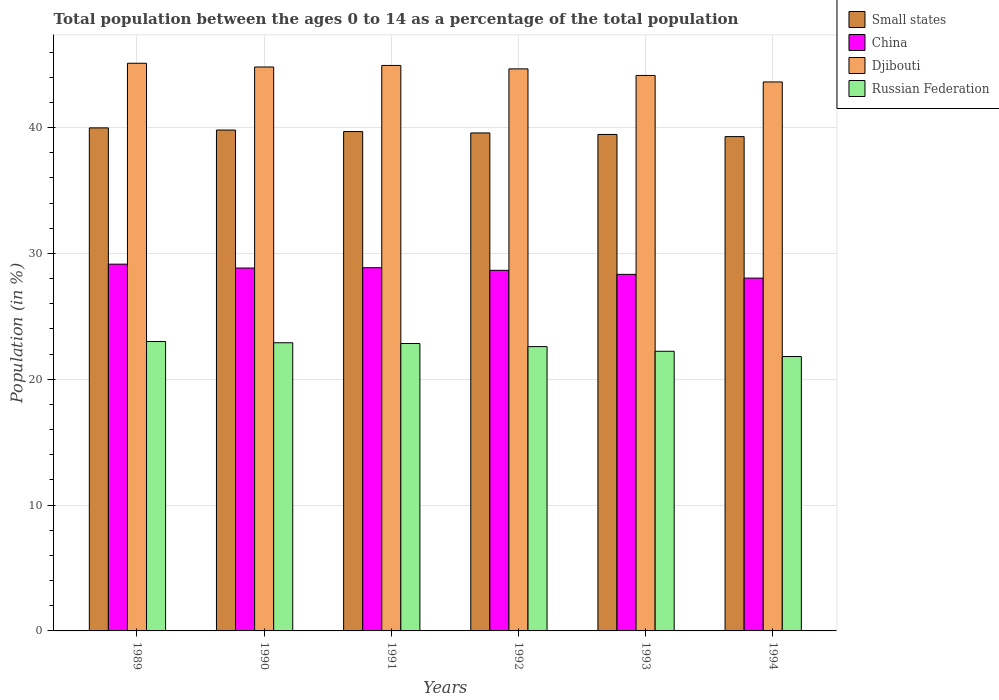Are the number of bars per tick equal to the number of legend labels?
Offer a terse response. Yes. Are the number of bars on each tick of the X-axis equal?
Keep it short and to the point. Yes. What is the label of the 2nd group of bars from the left?
Give a very brief answer. 1990. In how many cases, is the number of bars for a given year not equal to the number of legend labels?
Give a very brief answer. 0. What is the percentage of the population ages 0 to 14 in China in 1989?
Offer a terse response. 29.15. Across all years, what is the maximum percentage of the population ages 0 to 14 in Russian Federation?
Make the answer very short. 23. Across all years, what is the minimum percentage of the population ages 0 to 14 in Small states?
Provide a succinct answer. 39.29. What is the total percentage of the population ages 0 to 14 in China in the graph?
Provide a short and direct response. 171.9. What is the difference between the percentage of the population ages 0 to 14 in Russian Federation in 1991 and that in 1994?
Offer a terse response. 1.03. What is the difference between the percentage of the population ages 0 to 14 in Small states in 1989 and the percentage of the population ages 0 to 14 in Russian Federation in 1991?
Make the answer very short. 17.14. What is the average percentage of the population ages 0 to 14 in Russian Federation per year?
Keep it short and to the point. 22.56. In the year 1989, what is the difference between the percentage of the population ages 0 to 14 in Small states and percentage of the population ages 0 to 14 in China?
Give a very brief answer. 10.83. In how many years, is the percentage of the population ages 0 to 14 in China greater than 8?
Provide a short and direct response. 6. What is the ratio of the percentage of the population ages 0 to 14 in Russian Federation in 1990 to that in 1992?
Make the answer very short. 1.01. Is the percentage of the population ages 0 to 14 in China in 1990 less than that in 1994?
Your answer should be compact. No. Is the difference between the percentage of the population ages 0 to 14 in Small states in 1990 and 1991 greater than the difference between the percentage of the population ages 0 to 14 in China in 1990 and 1991?
Your answer should be very brief. Yes. What is the difference between the highest and the second highest percentage of the population ages 0 to 14 in China?
Provide a succinct answer. 0.28. What is the difference between the highest and the lowest percentage of the population ages 0 to 14 in Russian Federation?
Your answer should be compact. 1.19. In how many years, is the percentage of the population ages 0 to 14 in Djibouti greater than the average percentage of the population ages 0 to 14 in Djibouti taken over all years?
Ensure brevity in your answer.  4. Is the sum of the percentage of the population ages 0 to 14 in China in 1993 and 1994 greater than the maximum percentage of the population ages 0 to 14 in Small states across all years?
Your answer should be very brief. Yes. Is it the case that in every year, the sum of the percentage of the population ages 0 to 14 in Small states and percentage of the population ages 0 to 14 in Djibouti is greater than the sum of percentage of the population ages 0 to 14 in China and percentage of the population ages 0 to 14 in Russian Federation?
Your response must be concise. Yes. What does the 3rd bar from the left in 1990 represents?
Provide a short and direct response. Djibouti. What does the 2nd bar from the right in 1989 represents?
Ensure brevity in your answer.  Djibouti. Is it the case that in every year, the sum of the percentage of the population ages 0 to 14 in Small states and percentage of the population ages 0 to 14 in Djibouti is greater than the percentage of the population ages 0 to 14 in China?
Provide a short and direct response. Yes. Are all the bars in the graph horizontal?
Make the answer very short. No. How many years are there in the graph?
Your response must be concise. 6. What is the difference between two consecutive major ticks on the Y-axis?
Keep it short and to the point. 10. Does the graph contain any zero values?
Offer a very short reply. No. Does the graph contain grids?
Offer a terse response. Yes. Where does the legend appear in the graph?
Ensure brevity in your answer.  Top right. How are the legend labels stacked?
Offer a terse response. Vertical. What is the title of the graph?
Make the answer very short. Total population between the ages 0 to 14 as a percentage of the total population. Does "World" appear as one of the legend labels in the graph?
Ensure brevity in your answer.  No. What is the Population (in %) of Small states in 1989?
Make the answer very short. 39.98. What is the Population (in %) of China in 1989?
Your response must be concise. 29.15. What is the Population (in %) in Djibouti in 1989?
Your answer should be compact. 45.12. What is the Population (in %) of Russian Federation in 1989?
Ensure brevity in your answer.  23. What is the Population (in %) of Small states in 1990?
Offer a terse response. 39.81. What is the Population (in %) in China in 1990?
Provide a succinct answer. 28.84. What is the Population (in %) in Djibouti in 1990?
Your answer should be compact. 44.82. What is the Population (in %) in Russian Federation in 1990?
Ensure brevity in your answer.  22.9. What is the Population (in %) in Small states in 1991?
Give a very brief answer. 39.69. What is the Population (in %) in China in 1991?
Make the answer very short. 28.87. What is the Population (in %) of Djibouti in 1991?
Make the answer very short. 44.94. What is the Population (in %) of Russian Federation in 1991?
Your answer should be compact. 22.84. What is the Population (in %) in Small states in 1992?
Offer a very short reply. 39.58. What is the Population (in %) in China in 1992?
Keep it short and to the point. 28.66. What is the Population (in %) in Djibouti in 1992?
Provide a succinct answer. 44.67. What is the Population (in %) of Russian Federation in 1992?
Your response must be concise. 22.6. What is the Population (in %) of Small states in 1993?
Offer a very short reply. 39.46. What is the Population (in %) in China in 1993?
Keep it short and to the point. 28.34. What is the Population (in %) in Djibouti in 1993?
Your response must be concise. 44.15. What is the Population (in %) of Russian Federation in 1993?
Your answer should be very brief. 22.23. What is the Population (in %) of Small states in 1994?
Keep it short and to the point. 39.29. What is the Population (in %) of China in 1994?
Your response must be concise. 28.04. What is the Population (in %) in Djibouti in 1994?
Ensure brevity in your answer.  43.63. What is the Population (in %) in Russian Federation in 1994?
Offer a terse response. 21.81. Across all years, what is the maximum Population (in %) of Small states?
Offer a terse response. 39.98. Across all years, what is the maximum Population (in %) of China?
Offer a very short reply. 29.15. Across all years, what is the maximum Population (in %) of Djibouti?
Offer a terse response. 45.12. Across all years, what is the maximum Population (in %) of Russian Federation?
Give a very brief answer. 23. Across all years, what is the minimum Population (in %) of Small states?
Your response must be concise. 39.29. Across all years, what is the minimum Population (in %) in China?
Offer a very short reply. 28.04. Across all years, what is the minimum Population (in %) in Djibouti?
Ensure brevity in your answer.  43.63. Across all years, what is the minimum Population (in %) in Russian Federation?
Give a very brief answer. 21.81. What is the total Population (in %) in Small states in the graph?
Keep it short and to the point. 237.81. What is the total Population (in %) in China in the graph?
Ensure brevity in your answer.  171.9. What is the total Population (in %) in Djibouti in the graph?
Your response must be concise. 267.33. What is the total Population (in %) in Russian Federation in the graph?
Provide a succinct answer. 135.38. What is the difference between the Population (in %) in Small states in 1989 and that in 1990?
Provide a short and direct response. 0.17. What is the difference between the Population (in %) of China in 1989 and that in 1990?
Keep it short and to the point. 0.31. What is the difference between the Population (in %) in Djibouti in 1989 and that in 1990?
Provide a succinct answer. 0.3. What is the difference between the Population (in %) of Russian Federation in 1989 and that in 1990?
Your answer should be very brief. 0.1. What is the difference between the Population (in %) of Small states in 1989 and that in 1991?
Ensure brevity in your answer.  0.29. What is the difference between the Population (in %) of China in 1989 and that in 1991?
Offer a terse response. 0.28. What is the difference between the Population (in %) in Djibouti in 1989 and that in 1991?
Give a very brief answer. 0.17. What is the difference between the Population (in %) in Russian Federation in 1989 and that in 1991?
Ensure brevity in your answer.  0.16. What is the difference between the Population (in %) in Small states in 1989 and that in 1992?
Your response must be concise. 0.4. What is the difference between the Population (in %) of China in 1989 and that in 1992?
Make the answer very short. 0.49. What is the difference between the Population (in %) of Djibouti in 1989 and that in 1992?
Your answer should be compact. 0.45. What is the difference between the Population (in %) in Russian Federation in 1989 and that in 1992?
Provide a short and direct response. 0.4. What is the difference between the Population (in %) of Small states in 1989 and that in 1993?
Make the answer very short. 0.52. What is the difference between the Population (in %) in China in 1989 and that in 1993?
Ensure brevity in your answer.  0.81. What is the difference between the Population (in %) in Djibouti in 1989 and that in 1993?
Your answer should be very brief. 0.97. What is the difference between the Population (in %) in Russian Federation in 1989 and that in 1993?
Offer a very short reply. 0.78. What is the difference between the Population (in %) of Small states in 1989 and that in 1994?
Your answer should be compact. 0.69. What is the difference between the Population (in %) of China in 1989 and that in 1994?
Provide a succinct answer. 1.11. What is the difference between the Population (in %) in Djibouti in 1989 and that in 1994?
Provide a short and direct response. 1.48. What is the difference between the Population (in %) in Russian Federation in 1989 and that in 1994?
Ensure brevity in your answer.  1.19. What is the difference between the Population (in %) of Small states in 1990 and that in 1991?
Provide a short and direct response. 0.12. What is the difference between the Population (in %) of China in 1990 and that in 1991?
Offer a very short reply. -0.03. What is the difference between the Population (in %) of Djibouti in 1990 and that in 1991?
Your answer should be very brief. -0.12. What is the difference between the Population (in %) in Russian Federation in 1990 and that in 1991?
Your response must be concise. 0.06. What is the difference between the Population (in %) of Small states in 1990 and that in 1992?
Provide a succinct answer. 0.23. What is the difference between the Population (in %) in China in 1990 and that in 1992?
Your response must be concise. 0.18. What is the difference between the Population (in %) in Djibouti in 1990 and that in 1992?
Provide a succinct answer. 0.15. What is the difference between the Population (in %) in Russian Federation in 1990 and that in 1992?
Your response must be concise. 0.31. What is the difference between the Population (in %) of Small states in 1990 and that in 1993?
Provide a succinct answer. 0.35. What is the difference between the Population (in %) of China in 1990 and that in 1993?
Your answer should be compact. 0.5. What is the difference between the Population (in %) in Djibouti in 1990 and that in 1993?
Your answer should be very brief. 0.67. What is the difference between the Population (in %) in Russian Federation in 1990 and that in 1993?
Your answer should be very brief. 0.68. What is the difference between the Population (in %) in Small states in 1990 and that in 1994?
Your response must be concise. 0.52. What is the difference between the Population (in %) in China in 1990 and that in 1994?
Keep it short and to the point. 0.8. What is the difference between the Population (in %) in Djibouti in 1990 and that in 1994?
Your response must be concise. 1.19. What is the difference between the Population (in %) of Russian Federation in 1990 and that in 1994?
Give a very brief answer. 1.09. What is the difference between the Population (in %) in Small states in 1991 and that in 1992?
Provide a succinct answer. 0.11. What is the difference between the Population (in %) in China in 1991 and that in 1992?
Make the answer very short. 0.21. What is the difference between the Population (in %) of Djibouti in 1991 and that in 1992?
Your answer should be very brief. 0.27. What is the difference between the Population (in %) in Russian Federation in 1991 and that in 1992?
Your response must be concise. 0.24. What is the difference between the Population (in %) in Small states in 1991 and that in 1993?
Give a very brief answer. 0.23. What is the difference between the Population (in %) in China in 1991 and that in 1993?
Ensure brevity in your answer.  0.53. What is the difference between the Population (in %) of Djibouti in 1991 and that in 1993?
Make the answer very short. 0.79. What is the difference between the Population (in %) of Russian Federation in 1991 and that in 1993?
Offer a terse response. 0.62. What is the difference between the Population (in %) in Small states in 1991 and that in 1994?
Offer a very short reply. 0.4. What is the difference between the Population (in %) in China in 1991 and that in 1994?
Your answer should be compact. 0.83. What is the difference between the Population (in %) of Djibouti in 1991 and that in 1994?
Provide a short and direct response. 1.31. What is the difference between the Population (in %) of Russian Federation in 1991 and that in 1994?
Give a very brief answer. 1.03. What is the difference between the Population (in %) in Small states in 1992 and that in 1993?
Give a very brief answer. 0.12. What is the difference between the Population (in %) of China in 1992 and that in 1993?
Keep it short and to the point. 0.32. What is the difference between the Population (in %) of Djibouti in 1992 and that in 1993?
Provide a succinct answer. 0.52. What is the difference between the Population (in %) of Russian Federation in 1992 and that in 1993?
Your response must be concise. 0.37. What is the difference between the Population (in %) in Small states in 1992 and that in 1994?
Keep it short and to the point. 0.29. What is the difference between the Population (in %) of China in 1992 and that in 1994?
Give a very brief answer. 0.62. What is the difference between the Population (in %) in Djibouti in 1992 and that in 1994?
Ensure brevity in your answer.  1.04. What is the difference between the Population (in %) in Russian Federation in 1992 and that in 1994?
Your response must be concise. 0.79. What is the difference between the Population (in %) in Small states in 1993 and that in 1994?
Offer a terse response. 0.17. What is the difference between the Population (in %) in China in 1993 and that in 1994?
Your answer should be compact. 0.3. What is the difference between the Population (in %) in Djibouti in 1993 and that in 1994?
Offer a very short reply. 0.52. What is the difference between the Population (in %) in Russian Federation in 1993 and that in 1994?
Keep it short and to the point. 0.42. What is the difference between the Population (in %) in Small states in 1989 and the Population (in %) in China in 1990?
Keep it short and to the point. 11.14. What is the difference between the Population (in %) of Small states in 1989 and the Population (in %) of Djibouti in 1990?
Provide a succinct answer. -4.84. What is the difference between the Population (in %) in Small states in 1989 and the Population (in %) in Russian Federation in 1990?
Provide a short and direct response. 17.08. What is the difference between the Population (in %) in China in 1989 and the Population (in %) in Djibouti in 1990?
Provide a short and direct response. -15.67. What is the difference between the Population (in %) in China in 1989 and the Population (in %) in Russian Federation in 1990?
Offer a very short reply. 6.25. What is the difference between the Population (in %) in Djibouti in 1989 and the Population (in %) in Russian Federation in 1990?
Your response must be concise. 22.21. What is the difference between the Population (in %) of Small states in 1989 and the Population (in %) of China in 1991?
Ensure brevity in your answer.  11.11. What is the difference between the Population (in %) in Small states in 1989 and the Population (in %) in Djibouti in 1991?
Provide a short and direct response. -4.96. What is the difference between the Population (in %) of Small states in 1989 and the Population (in %) of Russian Federation in 1991?
Your answer should be very brief. 17.14. What is the difference between the Population (in %) of China in 1989 and the Population (in %) of Djibouti in 1991?
Your response must be concise. -15.79. What is the difference between the Population (in %) in China in 1989 and the Population (in %) in Russian Federation in 1991?
Offer a very short reply. 6.31. What is the difference between the Population (in %) of Djibouti in 1989 and the Population (in %) of Russian Federation in 1991?
Your answer should be compact. 22.28. What is the difference between the Population (in %) in Small states in 1989 and the Population (in %) in China in 1992?
Your response must be concise. 11.32. What is the difference between the Population (in %) of Small states in 1989 and the Population (in %) of Djibouti in 1992?
Offer a terse response. -4.69. What is the difference between the Population (in %) in Small states in 1989 and the Population (in %) in Russian Federation in 1992?
Make the answer very short. 17.38. What is the difference between the Population (in %) in China in 1989 and the Population (in %) in Djibouti in 1992?
Your response must be concise. -15.52. What is the difference between the Population (in %) of China in 1989 and the Population (in %) of Russian Federation in 1992?
Your answer should be compact. 6.55. What is the difference between the Population (in %) of Djibouti in 1989 and the Population (in %) of Russian Federation in 1992?
Provide a short and direct response. 22.52. What is the difference between the Population (in %) of Small states in 1989 and the Population (in %) of China in 1993?
Keep it short and to the point. 11.64. What is the difference between the Population (in %) in Small states in 1989 and the Population (in %) in Djibouti in 1993?
Your response must be concise. -4.17. What is the difference between the Population (in %) in Small states in 1989 and the Population (in %) in Russian Federation in 1993?
Make the answer very short. 17.75. What is the difference between the Population (in %) in China in 1989 and the Population (in %) in Djibouti in 1993?
Keep it short and to the point. -15. What is the difference between the Population (in %) of China in 1989 and the Population (in %) of Russian Federation in 1993?
Provide a short and direct response. 6.92. What is the difference between the Population (in %) in Djibouti in 1989 and the Population (in %) in Russian Federation in 1993?
Your answer should be compact. 22.89. What is the difference between the Population (in %) of Small states in 1989 and the Population (in %) of China in 1994?
Offer a very short reply. 11.94. What is the difference between the Population (in %) of Small states in 1989 and the Population (in %) of Djibouti in 1994?
Keep it short and to the point. -3.65. What is the difference between the Population (in %) of Small states in 1989 and the Population (in %) of Russian Federation in 1994?
Offer a terse response. 18.17. What is the difference between the Population (in %) of China in 1989 and the Population (in %) of Djibouti in 1994?
Your response must be concise. -14.48. What is the difference between the Population (in %) of China in 1989 and the Population (in %) of Russian Federation in 1994?
Offer a very short reply. 7.34. What is the difference between the Population (in %) of Djibouti in 1989 and the Population (in %) of Russian Federation in 1994?
Give a very brief answer. 23.31. What is the difference between the Population (in %) in Small states in 1990 and the Population (in %) in China in 1991?
Ensure brevity in your answer.  10.94. What is the difference between the Population (in %) of Small states in 1990 and the Population (in %) of Djibouti in 1991?
Your response must be concise. -5.13. What is the difference between the Population (in %) in Small states in 1990 and the Population (in %) in Russian Federation in 1991?
Your response must be concise. 16.97. What is the difference between the Population (in %) of China in 1990 and the Population (in %) of Djibouti in 1991?
Offer a very short reply. -16.1. What is the difference between the Population (in %) of China in 1990 and the Population (in %) of Russian Federation in 1991?
Ensure brevity in your answer.  6. What is the difference between the Population (in %) in Djibouti in 1990 and the Population (in %) in Russian Federation in 1991?
Provide a short and direct response. 21.98. What is the difference between the Population (in %) in Small states in 1990 and the Population (in %) in China in 1992?
Your response must be concise. 11.15. What is the difference between the Population (in %) of Small states in 1990 and the Population (in %) of Djibouti in 1992?
Your answer should be very brief. -4.86. What is the difference between the Population (in %) in Small states in 1990 and the Population (in %) in Russian Federation in 1992?
Your response must be concise. 17.21. What is the difference between the Population (in %) in China in 1990 and the Population (in %) in Djibouti in 1992?
Keep it short and to the point. -15.83. What is the difference between the Population (in %) in China in 1990 and the Population (in %) in Russian Federation in 1992?
Offer a very short reply. 6.24. What is the difference between the Population (in %) of Djibouti in 1990 and the Population (in %) of Russian Federation in 1992?
Give a very brief answer. 22.22. What is the difference between the Population (in %) of Small states in 1990 and the Population (in %) of China in 1993?
Provide a short and direct response. 11.47. What is the difference between the Population (in %) in Small states in 1990 and the Population (in %) in Djibouti in 1993?
Ensure brevity in your answer.  -4.34. What is the difference between the Population (in %) in Small states in 1990 and the Population (in %) in Russian Federation in 1993?
Your answer should be compact. 17.58. What is the difference between the Population (in %) in China in 1990 and the Population (in %) in Djibouti in 1993?
Your answer should be compact. -15.31. What is the difference between the Population (in %) of China in 1990 and the Population (in %) of Russian Federation in 1993?
Keep it short and to the point. 6.62. What is the difference between the Population (in %) in Djibouti in 1990 and the Population (in %) in Russian Federation in 1993?
Keep it short and to the point. 22.59. What is the difference between the Population (in %) in Small states in 1990 and the Population (in %) in China in 1994?
Provide a succinct answer. 11.77. What is the difference between the Population (in %) in Small states in 1990 and the Population (in %) in Djibouti in 1994?
Your response must be concise. -3.82. What is the difference between the Population (in %) of Small states in 1990 and the Population (in %) of Russian Federation in 1994?
Your response must be concise. 18. What is the difference between the Population (in %) in China in 1990 and the Population (in %) in Djibouti in 1994?
Give a very brief answer. -14.79. What is the difference between the Population (in %) in China in 1990 and the Population (in %) in Russian Federation in 1994?
Ensure brevity in your answer.  7.03. What is the difference between the Population (in %) of Djibouti in 1990 and the Population (in %) of Russian Federation in 1994?
Offer a very short reply. 23.01. What is the difference between the Population (in %) in Small states in 1991 and the Population (in %) in China in 1992?
Offer a very short reply. 11.03. What is the difference between the Population (in %) in Small states in 1991 and the Population (in %) in Djibouti in 1992?
Your response must be concise. -4.98. What is the difference between the Population (in %) in Small states in 1991 and the Population (in %) in Russian Federation in 1992?
Your answer should be very brief. 17.09. What is the difference between the Population (in %) of China in 1991 and the Population (in %) of Djibouti in 1992?
Keep it short and to the point. -15.8. What is the difference between the Population (in %) of China in 1991 and the Population (in %) of Russian Federation in 1992?
Make the answer very short. 6.27. What is the difference between the Population (in %) of Djibouti in 1991 and the Population (in %) of Russian Federation in 1992?
Provide a short and direct response. 22.35. What is the difference between the Population (in %) of Small states in 1991 and the Population (in %) of China in 1993?
Offer a very short reply. 11.35. What is the difference between the Population (in %) of Small states in 1991 and the Population (in %) of Djibouti in 1993?
Provide a succinct answer. -4.46. What is the difference between the Population (in %) of Small states in 1991 and the Population (in %) of Russian Federation in 1993?
Keep it short and to the point. 17.46. What is the difference between the Population (in %) in China in 1991 and the Population (in %) in Djibouti in 1993?
Your answer should be very brief. -15.28. What is the difference between the Population (in %) in China in 1991 and the Population (in %) in Russian Federation in 1993?
Offer a terse response. 6.64. What is the difference between the Population (in %) of Djibouti in 1991 and the Population (in %) of Russian Federation in 1993?
Offer a very short reply. 22.72. What is the difference between the Population (in %) in Small states in 1991 and the Population (in %) in China in 1994?
Ensure brevity in your answer.  11.65. What is the difference between the Population (in %) of Small states in 1991 and the Population (in %) of Djibouti in 1994?
Keep it short and to the point. -3.94. What is the difference between the Population (in %) of Small states in 1991 and the Population (in %) of Russian Federation in 1994?
Ensure brevity in your answer.  17.88. What is the difference between the Population (in %) in China in 1991 and the Population (in %) in Djibouti in 1994?
Keep it short and to the point. -14.76. What is the difference between the Population (in %) in China in 1991 and the Population (in %) in Russian Federation in 1994?
Provide a succinct answer. 7.06. What is the difference between the Population (in %) of Djibouti in 1991 and the Population (in %) of Russian Federation in 1994?
Your answer should be very brief. 23.13. What is the difference between the Population (in %) in Small states in 1992 and the Population (in %) in China in 1993?
Your response must be concise. 11.24. What is the difference between the Population (in %) in Small states in 1992 and the Population (in %) in Djibouti in 1993?
Make the answer very short. -4.57. What is the difference between the Population (in %) in Small states in 1992 and the Population (in %) in Russian Federation in 1993?
Keep it short and to the point. 17.35. What is the difference between the Population (in %) in China in 1992 and the Population (in %) in Djibouti in 1993?
Your response must be concise. -15.49. What is the difference between the Population (in %) in China in 1992 and the Population (in %) in Russian Federation in 1993?
Provide a short and direct response. 6.43. What is the difference between the Population (in %) of Djibouti in 1992 and the Population (in %) of Russian Federation in 1993?
Keep it short and to the point. 22.44. What is the difference between the Population (in %) of Small states in 1992 and the Population (in %) of China in 1994?
Offer a very short reply. 11.54. What is the difference between the Population (in %) of Small states in 1992 and the Population (in %) of Djibouti in 1994?
Your answer should be compact. -4.05. What is the difference between the Population (in %) in Small states in 1992 and the Population (in %) in Russian Federation in 1994?
Your answer should be compact. 17.77. What is the difference between the Population (in %) in China in 1992 and the Population (in %) in Djibouti in 1994?
Keep it short and to the point. -14.97. What is the difference between the Population (in %) in China in 1992 and the Population (in %) in Russian Federation in 1994?
Your response must be concise. 6.85. What is the difference between the Population (in %) of Djibouti in 1992 and the Population (in %) of Russian Federation in 1994?
Your response must be concise. 22.86. What is the difference between the Population (in %) in Small states in 1993 and the Population (in %) in China in 1994?
Make the answer very short. 11.42. What is the difference between the Population (in %) in Small states in 1993 and the Population (in %) in Djibouti in 1994?
Offer a very short reply. -4.17. What is the difference between the Population (in %) in Small states in 1993 and the Population (in %) in Russian Federation in 1994?
Your answer should be very brief. 17.65. What is the difference between the Population (in %) in China in 1993 and the Population (in %) in Djibouti in 1994?
Offer a very short reply. -15.29. What is the difference between the Population (in %) in China in 1993 and the Population (in %) in Russian Federation in 1994?
Your response must be concise. 6.53. What is the difference between the Population (in %) in Djibouti in 1993 and the Population (in %) in Russian Federation in 1994?
Give a very brief answer. 22.34. What is the average Population (in %) in Small states per year?
Provide a short and direct response. 39.63. What is the average Population (in %) of China per year?
Your response must be concise. 28.65. What is the average Population (in %) of Djibouti per year?
Your response must be concise. 44.56. What is the average Population (in %) in Russian Federation per year?
Offer a terse response. 22.56. In the year 1989, what is the difference between the Population (in %) in Small states and Population (in %) in China?
Give a very brief answer. 10.83. In the year 1989, what is the difference between the Population (in %) of Small states and Population (in %) of Djibouti?
Offer a very short reply. -5.14. In the year 1989, what is the difference between the Population (in %) of Small states and Population (in %) of Russian Federation?
Ensure brevity in your answer.  16.98. In the year 1989, what is the difference between the Population (in %) in China and Population (in %) in Djibouti?
Offer a terse response. -15.97. In the year 1989, what is the difference between the Population (in %) of China and Population (in %) of Russian Federation?
Your answer should be very brief. 6.15. In the year 1989, what is the difference between the Population (in %) of Djibouti and Population (in %) of Russian Federation?
Make the answer very short. 22.12. In the year 1990, what is the difference between the Population (in %) in Small states and Population (in %) in China?
Your answer should be very brief. 10.97. In the year 1990, what is the difference between the Population (in %) of Small states and Population (in %) of Djibouti?
Give a very brief answer. -5.01. In the year 1990, what is the difference between the Population (in %) in Small states and Population (in %) in Russian Federation?
Keep it short and to the point. 16.91. In the year 1990, what is the difference between the Population (in %) in China and Population (in %) in Djibouti?
Keep it short and to the point. -15.98. In the year 1990, what is the difference between the Population (in %) in China and Population (in %) in Russian Federation?
Keep it short and to the point. 5.94. In the year 1990, what is the difference between the Population (in %) in Djibouti and Population (in %) in Russian Federation?
Provide a succinct answer. 21.92. In the year 1991, what is the difference between the Population (in %) of Small states and Population (in %) of China?
Make the answer very short. 10.82. In the year 1991, what is the difference between the Population (in %) in Small states and Population (in %) in Djibouti?
Keep it short and to the point. -5.25. In the year 1991, what is the difference between the Population (in %) in Small states and Population (in %) in Russian Federation?
Offer a very short reply. 16.85. In the year 1991, what is the difference between the Population (in %) in China and Population (in %) in Djibouti?
Provide a succinct answer. -16.07. In the year 1991, what is the difference between the Population (in %) in China and Population (in %) in Russian Federation?
Ensure brevity in your answer.  6.03. In the year 1991, what is the difference between the Population (in %) of Djibouti and Population (in %) of Russian Federation?
Keep it short and to the point. 22.1. In the year 1992, what is the difference between the Population (in %) in Small states and Population (in %) in China?
Your response must be concise. 10.92. In the year 1992, what is the difference between the Population (in %) in Small states and Population (in %) in Djibouti?
Offer a very short reply. -5.09. In the year 1992, what is the difference between the Population (in %) in Small states and Population (in %) in Russian Federation?
Make the answer very short. 16.98. In the year 1992, what is the difference between the Population (in %) of China and Population (in %) of Djibouti?
Give a very brief answer. -16.01. In the year 1992, what is the difference between the Population (in %) in China and Population (in %) in Russian Federation?
Your answer should be very brief. 6.06. In the year 1992, what is the difference between the Population (in %) of Djibouti and Population (in %) of Russian Federation?
Make the answer very short. 22.07. In the year 1993, what is the difference between the Population (in %) of Small states and Population (in %) of China?
Your response must be concise. 11.12. In the year 1993, what is the difference between the Population (in %) in Small states and Population (in %) in Djibouti?
Give a very brief answer. -4.69. In the year 1993, what is the difference between the Population (in %) of Small states and Population (in %) of Russian Federation?
Provide a short and direct response. 17.23. In the year 1993, what is the difference between the Population (in %) of China and Population (in %) of Djibouti?
Give a very brief answer. -15.81. In the year 1993, what is the difference between the Population (in %) of China and Population (in %) of Russian Federation?
Give a very brief answer. 6.11. In the year 1993, what is the difference between the Population (in %) in Djibouti and Population (in %) in Russian Federation?
Provide a succinct answer. 21.92. In the year 1994, what is the difference between the Population (in %) in Small states and Population (in %) in China?
Your answer should be very brief. 11.25. In the year 1994, what is the difference between the Population (in %) in Small states and Population (in %) in Djibouti?
Provide a short and direct response. -4.34. In the year 1994, what is the difference between the Population (in %) of Small states and Population (in %) of Russian Federation?
Provide a short and direct response. 17.48. In the year 1994, what is the difference between the Population (in %) in China and Population (in %) in Djibouti?
Your answer should be very brief. -15.59. In the year 1994, what is the difference between the Population (in %) in China and Population (in %) in Russian Federation?
Offer a terse response. 6.23. In the year 1994, what is the difference between the Population (in %) of Djibouti and Population (in %) of Russian Federation?
Your answer should be compact. 21.82. What is the ratio of the Population (in %) of China in 1989 to that in 1990?
Offer a terse response. 1.01. What is the ratio of the Population (in %) in Djibouti in 1989 to that in 1990?
Give a very brief answer. 1.01. What is the ratio of the Population (in %) in Russian Federation in 1989 to that in 1990?
Make the answer very short. 1. What is the ratio of the Population (in %) in Small states in 1989 to that in 1991?
Your answer should be compact. 1.01. What is the ratio of the Population (in %) of China in 1989 to that in 1991?
Your answer should be very brief. 1.01. What is the ratio of the Population (in %) in Djibouti in 1989 to that in 1991?
Provide a succinct answer. 1. What is the ratio of the Population (in %) of China in 1989 to that in 1992?
Offer a terse response. 1.02. What is the ratio of the Population (in %) in Djibouti in 1989 to that in 1992?
Offer a very short reply. 1.01. What is the ratio of the Population (in %) of Russian Federation in 1989 to that in 1992?
Provide a succinct answer. 1.02. What is the ratio of the Population (in %) in Small states in 1989 to that in 1993?
Ensure brevity in your answer.  1.01. What is the ratio of the Population (in %) in China in 1989 to that in 1993?
Your response must be concise. 1.03. What is the ratio of the Population (in %) in Russian Federation in 1989 to that in 1993?
Provide a succinct answer. 1.03. What is the ratio of the Population (in %) of Small states in 1989 to that in 1994?
Offer a very short reply. 1.02. What is the ratio of the Population (in %) of China in 1989 to that in 1994?
Ensure brevity in your answer.  1.04. What is the ratio of the Population (in %) of Djibouti in 1989 to that in 1994?
Your answer should be very brief. 1.03. What is the ratio of the Population (in %) of Russian Federation in 1989 to that in 1994?
Keep it short and to the point. 1.05. What is the ratio of the Population (in %) of Small states in 1990 to that in 1992?
Your answer should be very brief. 1.01. What is the ratio of the Population (in %) in Djibouti in 1990 to that in 1992?
Your response must be concise. 1. What is the ratio of the Population (in %) in Russian Federation in 1990 to that in 1992?
Ensure brevity in your answer.  1.01. What is the ratio of the Population (in %) of Small states in 1990 to that in 1993?
Offer a very short reply. 1.01. What is the ratio of the Population (in %) of China in 1990 to that in 1993?
Give a very brief answer. 1.02. What is the ratio of the Population (in %) in Djibouti in 1990 to that in 1993?
Give a very brief answer. 1.02. What is the ratio of the Population (in %) in Russian Federation in 1990 to that in 1993?
Offer a terse response. 1.03. What is the ratio of the Population (in %) of Small states in 1990 to that in 1994?
Ensure brevity in your answer.  1.01. What is the ratio of the Population (in %) of China in 1990 to that in 1994?
Keep it short and to the point. 1.03. What is the ratio of the Population (in %) in Djibouti in 1990 to that in 1994?
Give a very brief answer. 1.03. What is the ratio of the Population (in %) in Russian Federation in 1990 to that in 1994?
Offer a terse response. 1.05. What is the ratio of the Population (in %) in Small states in 1991 to that in 1992?
Your response must be concise. 1. What is the ratio of the Population (in %) of Djibouti in 1991 to that in 1992?
Provide a short and direct response. 1.01. What is the ratio of the Population (in %) in Russian Federation in 1991 to that in 1992?
Make the answer very short. 1.01. What is the ratio of the Population (in %) of Small states in 1991 to that in 1993?
Your answer should be very brief. 1.01. What is the ratio of the Population (in %) of China in 1991 to that in 1993?
Provide a short and direct response. 1.02. What is the ratio of the Population (in %) of Russian Federation in 1991 to that in 1993?
Offer a very short reply. 1.03. What is the ratio of the Population (in %) of Small states in 1991 to that in 1994?
Give a very brief answer. 1.01. What is the ratio of the Population (in %) in China in 1991 to that in 1994?
Offer a very short reply. 1.03. What is the ratio of the Population (in %) in Russian Federation in 1991 to that in 1994?
Offer a very short reply. 1.05. What is the ratio of the Population (in %) in China in 1992 to that in 1993?
Your response must be concise. 1.01. What is the ratio of the Population (in %) of Djibouti in 1992 to that in 1993?
Your answer should be very brief. 1.01. What is the ratio of the Population (in %) of Russian Federation in 1992 to that in 1993?
Make the answer very short. 1.02. What is the ratio of the Population (in %) in Small states in 1992 to that in 1994?
Keep it short and to the point. 1.01. What is the ratio of the Population (in %) in China in 1992 to that in 1994?
Give a very brief answer. 1.02. What is the ratio of the Population (in %) in Djibouti in 1992 to that in 1994?
Ensure brevity in your answer.  1.02. What is the ratio of the Population (in %) in Russian Federation in 1992 to that in 1994?
Give a very brief answer. 1.04. What is the ratio of the Population (in %) in Small states in 1993 to that in 1994?
Make the answer very short. 1. What is the ratio of the Population (in %) of China in 1993 to that in 1994?
Keep it short and to the point. 1.01. What is the ratio of the Population (in %) in Djibouti in 1993 to that in 1994?
Your response must be concise. 1.01. What is the ratio of the Population (in %) in Russian Federation in 1993 to that in 1994?
Ensure brevity in your answer.  1.02. What is the difference between the highest and the second highest Population (in %) in Small states?
Provide a short and direct response. 0.17. What is the difference between the highest and the second highest Population (in %) of China?
Make the answer very short. 0.28. What is the difference between the highest and the second highest Population (in %) in Djibouti?
Give a very brief answer. 0.17. What is the difference between the highest and the second highest Population (in %) of Russian Federation?
Your response must be concise. 0.1. What is the difference between the highest and the lowest Population (in %) in Small states?
Make the answer very short. 0.69. What is the difference between the highest and the lowest Population (in %) of China?
Provide a short and direct response. 1.11. What is the difference between the highest and the lowest Population (in %) in Djibouti?
Your answer should be compact. 1.48. What is the difference between the highest and the lowest Population (in %) of Russian Federation?
Provide a succinct answer. 1.19. 